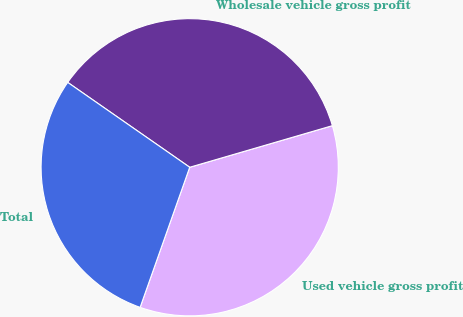Convert chart. <chart><loc_0><loc_0><loc_500><loc_500><pie_chart><fcel>Used vehicle gross profit<fcel>Wholesale vehicle gross profit<fcel>Total<nl><fcel>34.93%<fcel>35.81%<fcel>29.26%<nl></chart> 